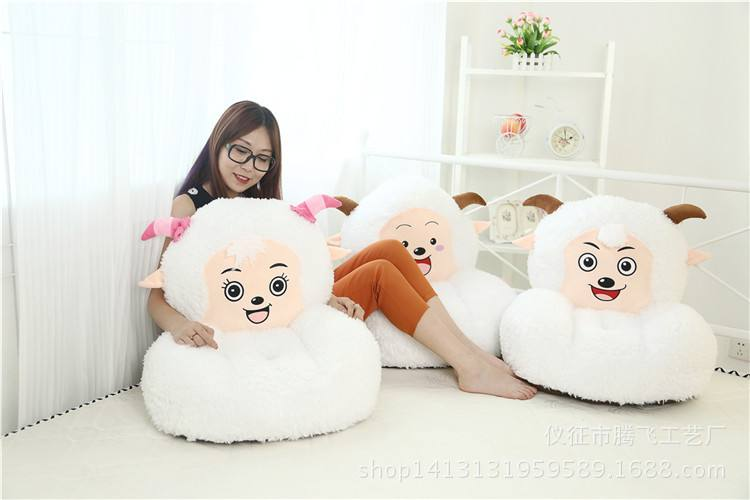What colors are predominant in the room? The room is predominantly white, which provides a bright and clean backdrop to the colorful details such as the pink bows on the sheep sofas and the small decorative elements on the shelving. 